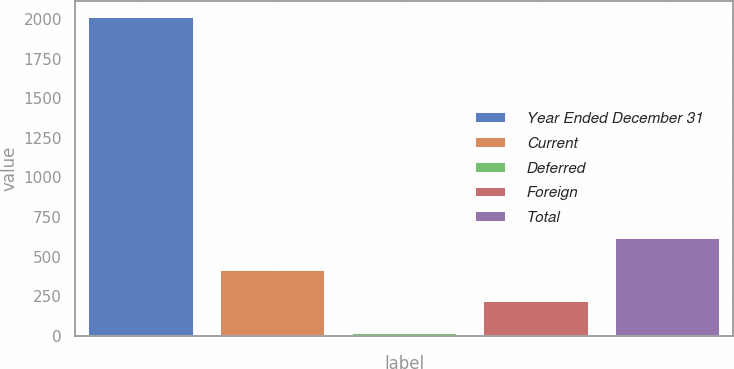Convert chart. <chart><loc_0><loc_0><loc_500><loc_500><bar_chart><fcel>Year Ended December 31<fcel>Current<fcel>Deferred<fcel>Foreign<fcel>Total<nl><fcel>2012<fcel>416.8<fcel>18<fcel>217.4<fcel>616.2<nl></chart> 